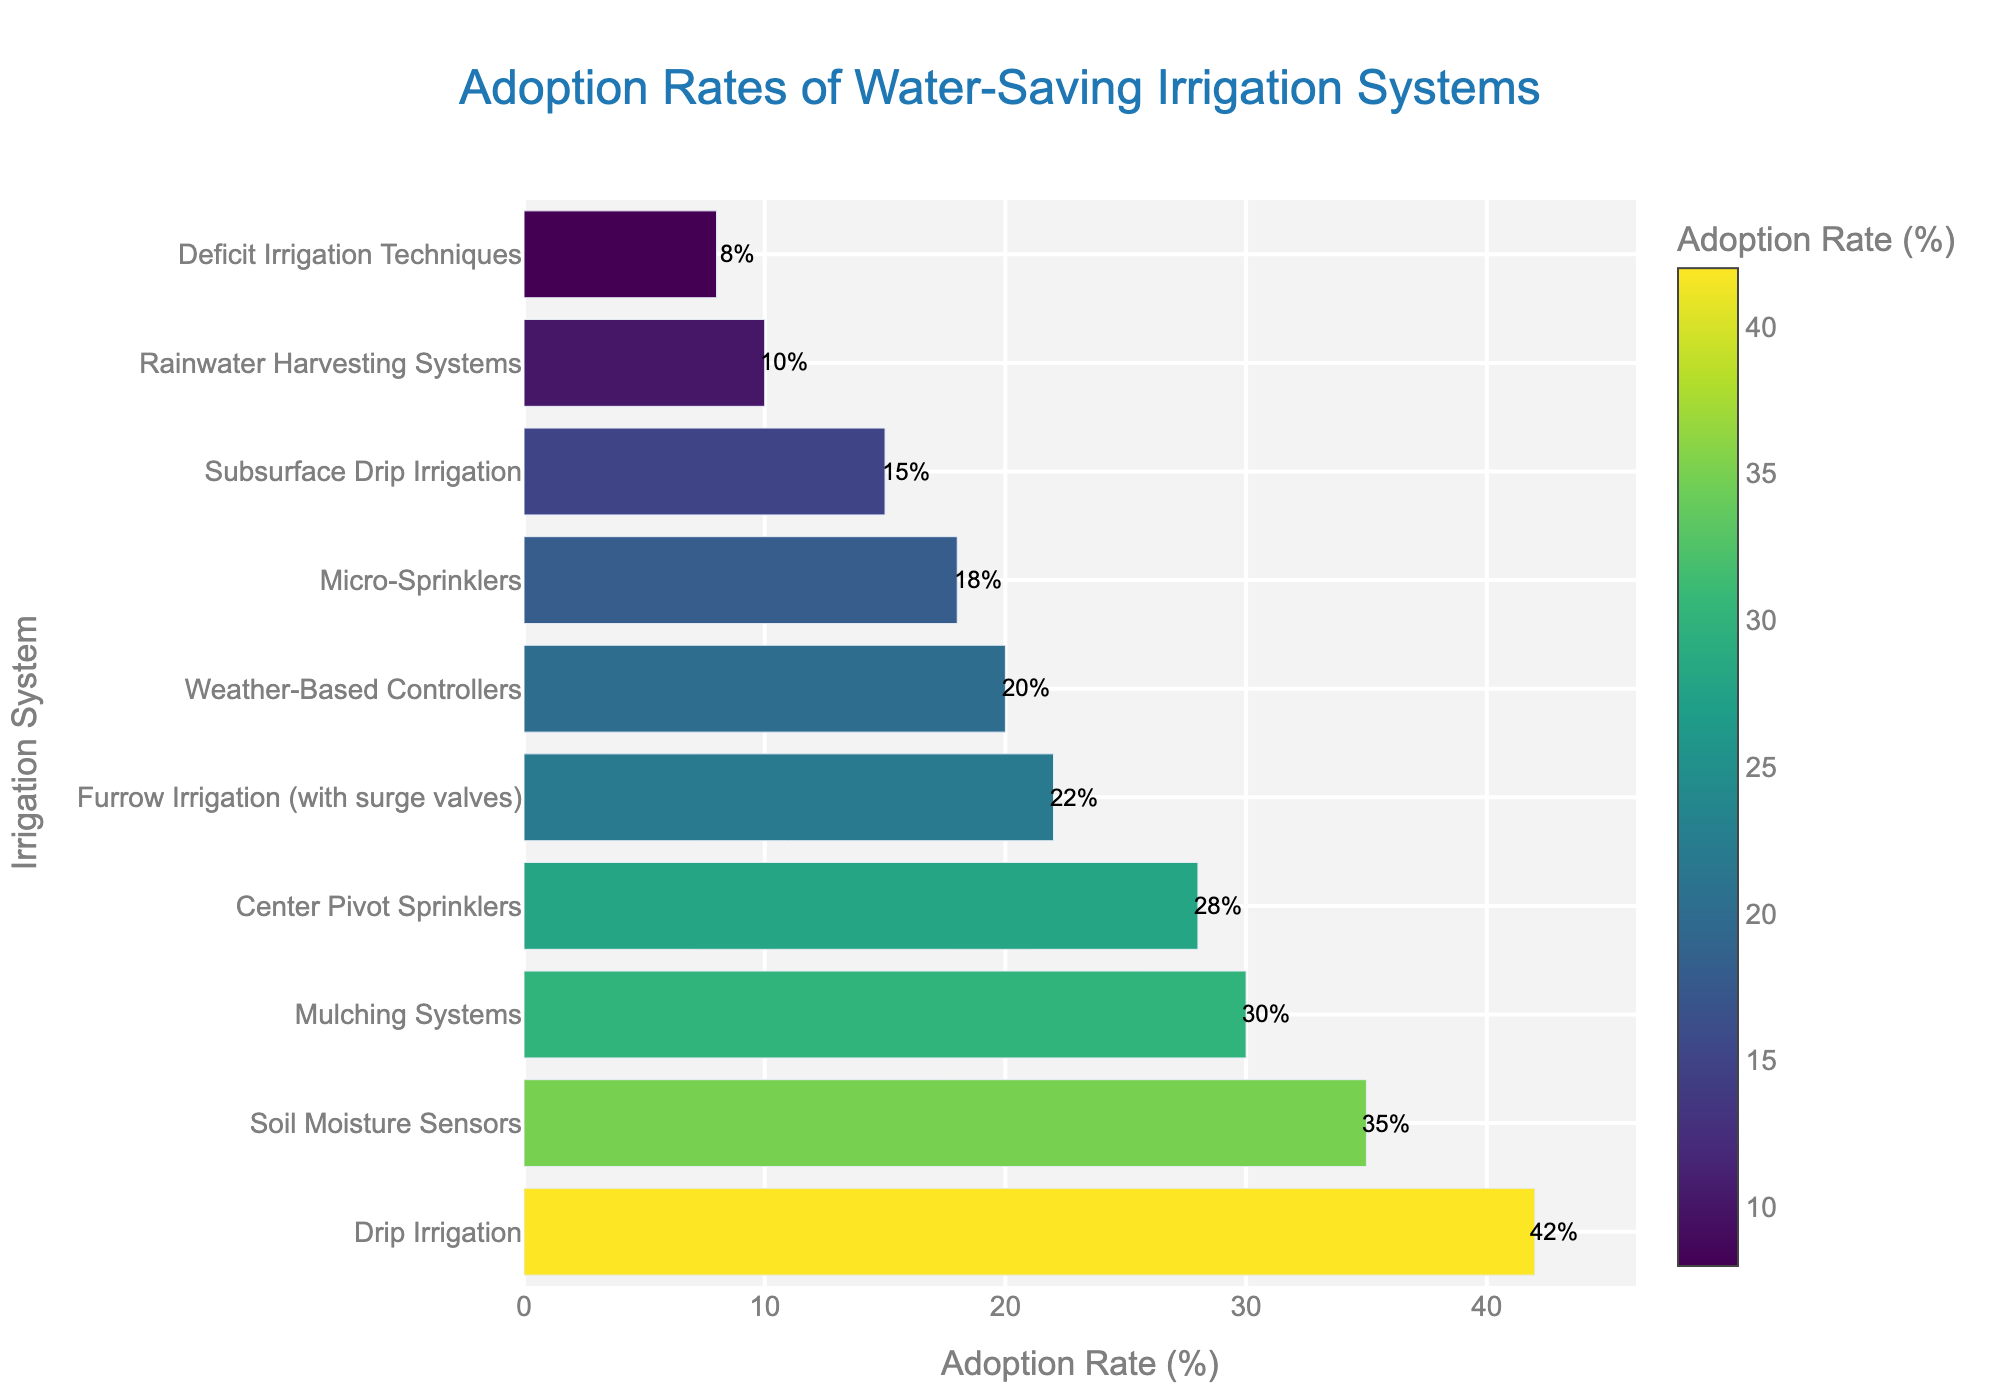Which irrigation system has the highest adoption rate? The bar corresponding to Drip Irrigation is the tallest and positioned at the top of the chart, indicating it has the highest adoption rate.
Answer: Drip Irrigation How much higher is the adoption rate of Soil Moisture Sensors compared to Micro-Sprinklers? The adoption rates are 35% for Soil Moisture Sensors and 18% for Micro-Sprinklers. The difference is calculated as 35% - 18%.
Answer: 17% Which irrigation system has a lower adoption rate: Deficit Irrigation Techniques or Rainwater Harvesting Systems? The adoption rates are 8% for Deficit Irrigation Techniques and 10% for Rainwater Harvesting Systems. Comparing these two, 8% is lower than 10%.
Answer: Deficit Irrigation Techniques What is the combined adoption rate of Center Pivot Sprinklers and Mulching Systems? The adoption rates are 28% for Center Pivot Sprinklers and 30% for Mulching Systems. Combined, this is calculated as 28% + 30%.
Answer: 58% Is the adoption rate of Furrow Irrigation (with surge valves) greater than or equal to that of Weather-Based Controllers? The adoption rates are 22% for Furrow Irrigation (with surge valves) and 20% for Weather-Based Controllers. 22% is greater than 20%.
Answer: Greater What is the average adoption rate of the top three systems? The top three systems are Drip Irrigation (42%), Soil Moisture Sensors (35%), and Mulching Systems (30%). The average is calculated as (42% + 35% + 30%) / 3.
Answer: 35.67% Which two systems have the smallest difference in adoption rates? By examining the differences between the adoption rates, Furrow Irrigation (with surge valves) 22% and Weather-Based Controllers 20% have the smallest difference, which is 2%.
Answer: Furrow Irrigation (with surge valves) and Weather-Based Controllers What percentage of irrigation systems have an adoption rate below 20%? There are 10 irrigation systems, and 4 of them (Micro-Sprinklers 18%, Subsurface Drip Irrigation 15%, Rainwater Harvesting Systems 10%, Deficit Irrigation Techniques 8%) have an adoption rate below 20%. The percentage is calculated as (4/10) * 100.
Answer: 40% How does the adoption rate of Weather-Based Controllers compare to that of Subsurface Drip Irrigation? The adoption rates are 20% for Weather-Based Controllers and 15% for Subsurface Drip Irrigation. Comparing these, 20% is higher than 15%.
Answer: Higher What is the difference between the highest and lowest adoption rates? The highest adoption rate is Drip Irrigation at 42%, and the lowest is Deficit Irrigation Techniques at 8%. The difference is calculated as 42% - 8%.
Answer: 34% 